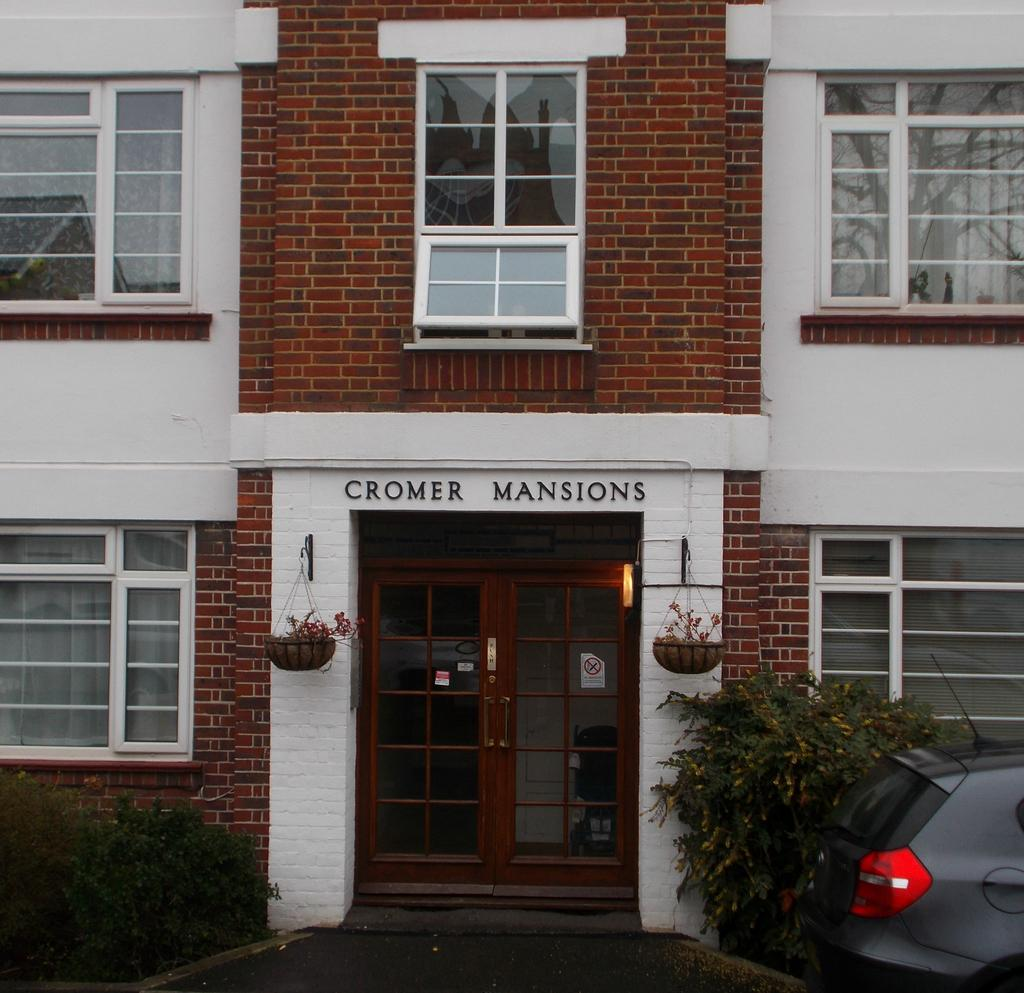What type of structure is present in the picture? There is a building in the picture. What features can be observed on the building? The building has doors and windows. Are there any decorative elements attached to the building? Yes, there are flower pots attached to the wall of the building. What else is present in the picture besides the building? There is a vehicle and plants in the picture. Is there any text or writing on the building? Yes, there is something written on the building. How many chickens are roaming around the building in the picture? There are no chickens present in the image. What type of form is being used to create the vessel in the picture? There is no vessel present in the image. 